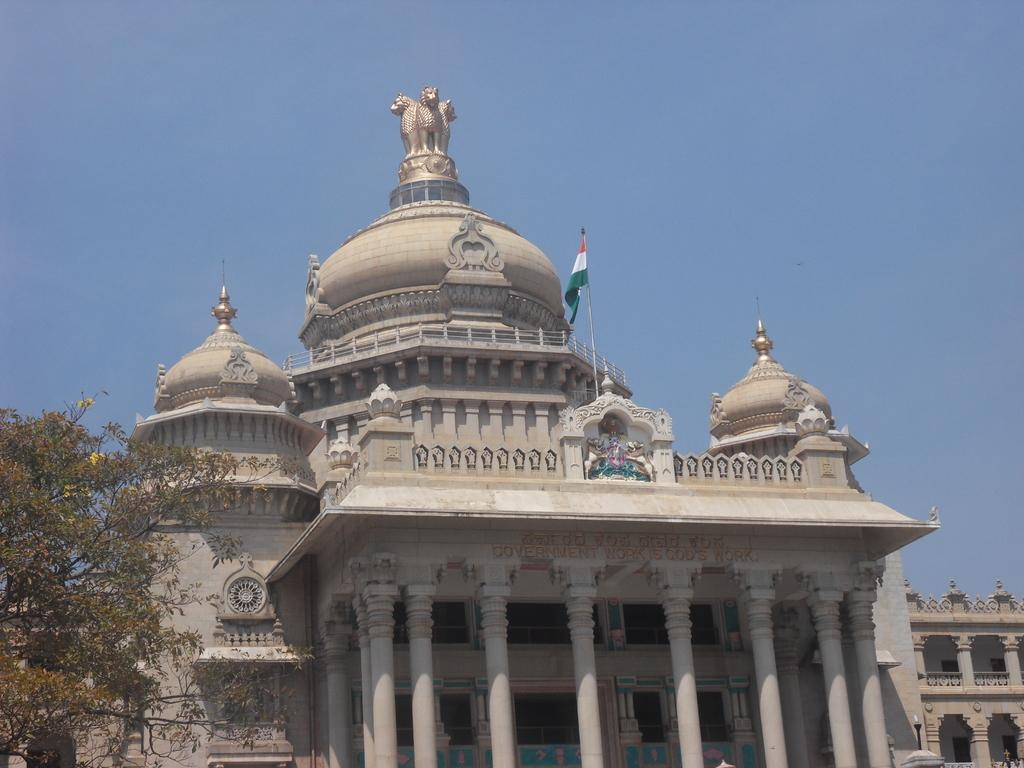What is the color of the sky in the image? The sky is blue in color. What type of structure can be seen in the image? There is a building in the image. What is located above the building? There is a flag above the building. What architectural feature is visible in the image? Pillars are visible in the image. What type of vegetation is present in the image? There is a tree in the image. Where is the library located in the image? There is no library mentioned or visible in the image. What type of dock can be seen near the tree in the image? There is no dock present in the image; it only features a tree and other elements mentioned in the facts. 